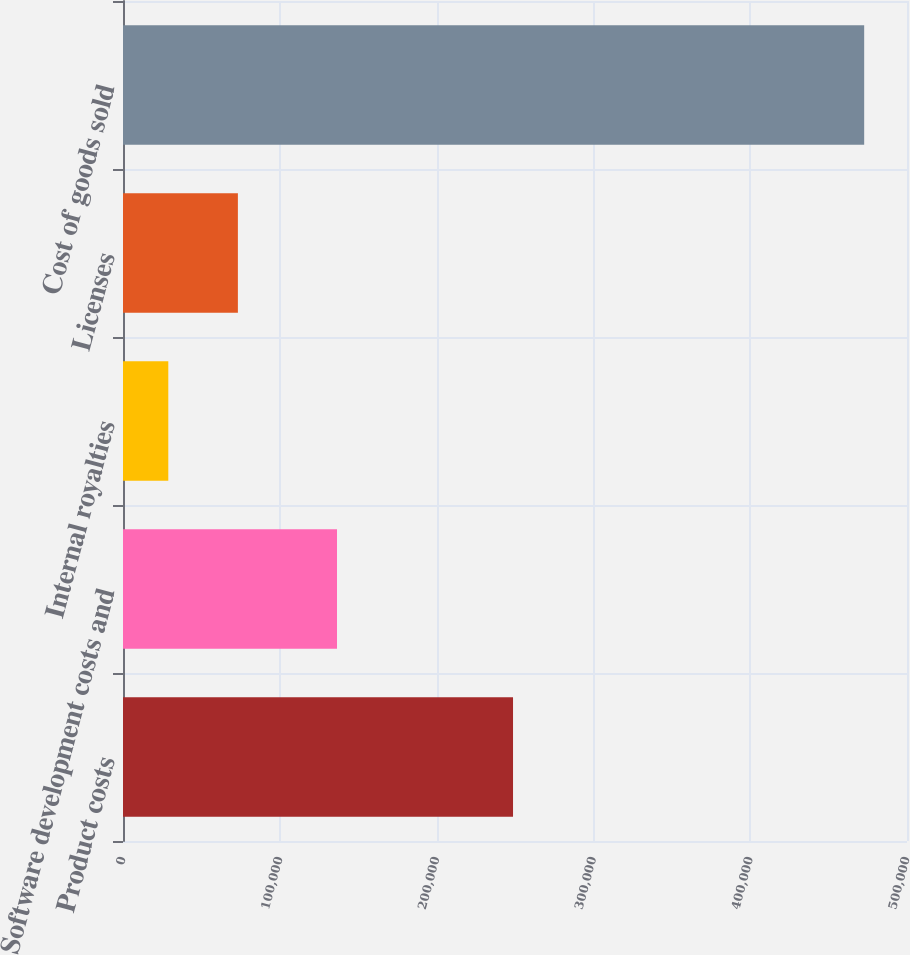<chart> <loc_0><loc_0><loc_500><loc_500><bar_chart><fcel>Product costs<fcel>Software development costs and<fcel>Internal royalties<fcel>Licenses<fcel>Cost of goods sold<nl><fcel>248744<fcel>136485<fcel>28892<fcel>73271.8<fcel>472690<nl></chart> 